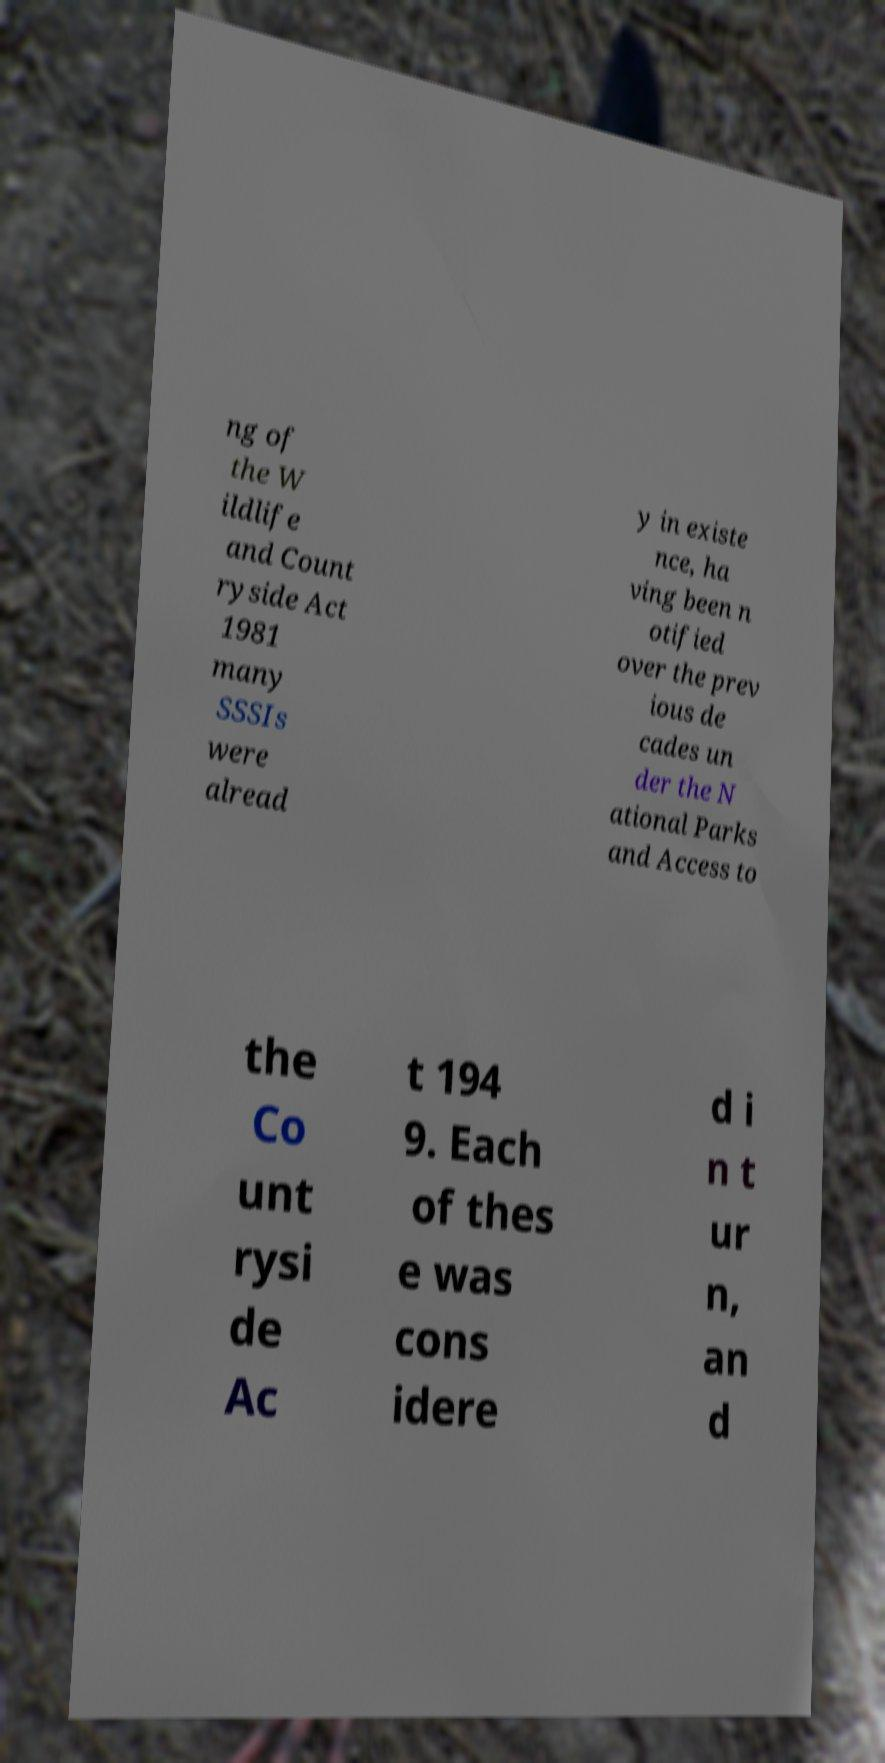For documentation purposes, I need the text within this image transcribed. Could you provide that? ng of the W ildlife and Count ryside Act 1981 many SSSIs were alread y in existe nce, ha ving been n otified over the prev ious de cades un der the N ational Parks and Access to the Co unt rysi de Ac t 194 9. Each of thes e was cons idere d i n t ur n, an d 